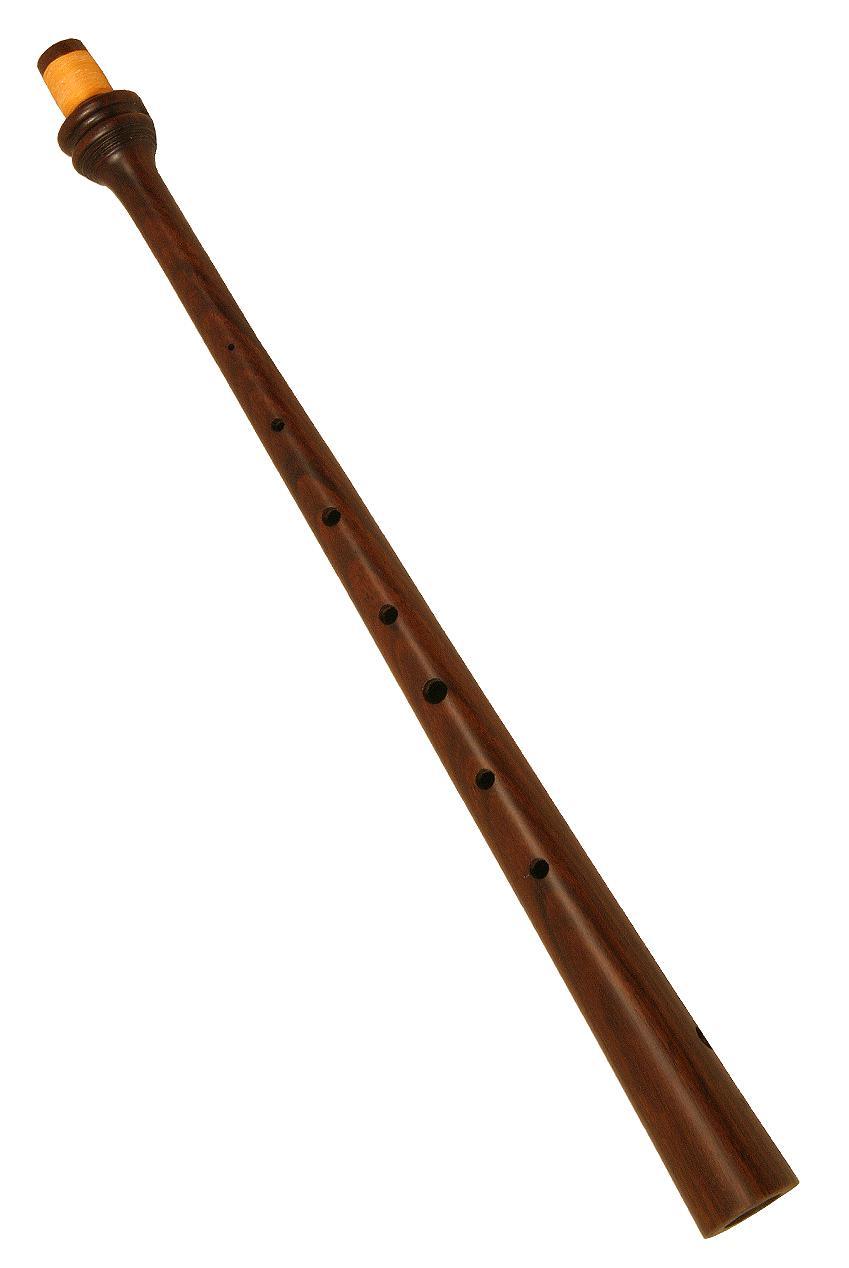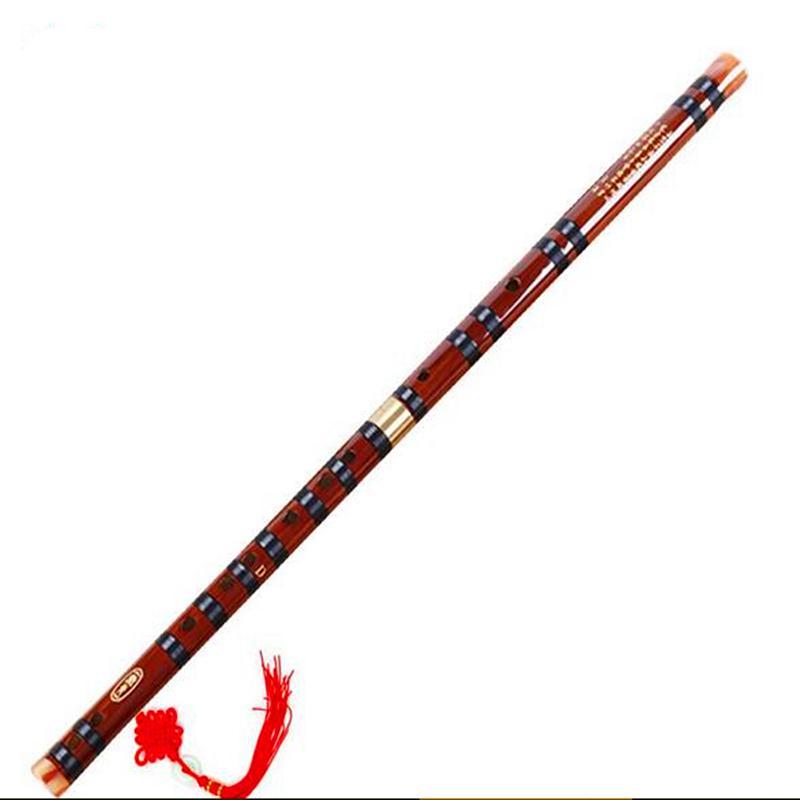The first image is the image on the left, the second image is the image on the right. For the images displayed, is the sentence "The right image contains exactly one flute like musical instrument." factually correct? Answer yes or no. Yes. The first image is the image on the left, the second image is the image on the right. For the images displayed, is the sentence "The left and right image contains a total of two flutes." factually correct? Answer yes or no. Yes. 